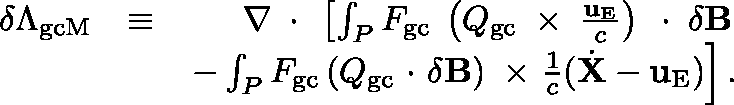<formula> <loc_0><loc_0><loc_500><loc_500>\begin{array} { r l r } { \delta \Lambda _ { g c M } } & { \equiv } & { \nabla \, \boldmath \cdot \, \left [ \int _ { P } F _ { g c } \, \left ( \mathbb { Q } _ { g c } \, \boldmath \times \, \frac { { u } _ { E } } { c } \right ) \, \boldmath \cdot \, \delta { B } } \\ & { - \int _ { P } F _ { g c } \left ( \mathbb { Q } _ { g c } \boldmath \cdot \delta { B } \right ) \boldmath \times \frac { 1 } { c } ( \dot { X } - { u } _ { E } ) \right ] . } \end{array}</formula> 